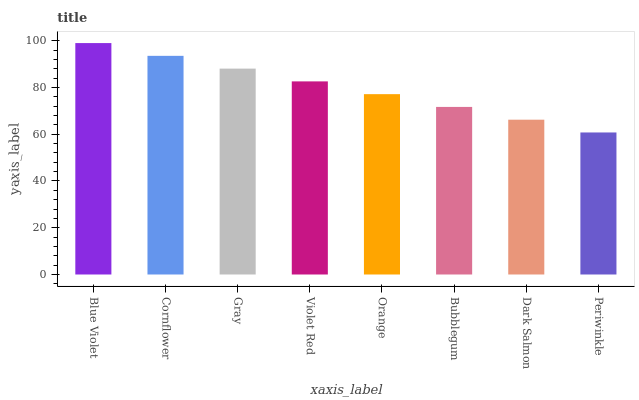Is Periwinkle the minimum?
Answer yes or no. Yes. Is Blue Violet the maximum?
Answer yes or no. Yes. Is Cornflower the minimum?
Answer yes or no. No. Is Cornflower the maximum?
Answer yes or no. No. Is Blue Violet greater than Cornflower?
Answer yes or no. Yes. Is Cornflower less than Blue Violet?
Answer yes or no. Yes. Is Cornflower greater than Blue Violet?
Answer yes or no. No. Is Blue Violet less than Cornflower?
Answer yes or no. No. Is Violet Red the high median?
Answer yes or no. Yes. Is Orange the low median?
Answer yes or no. Yes. Is Periwinkle the high median?
Answer yes or no. No. Is Bubblegum the low median?
Answer yes or no. No. 